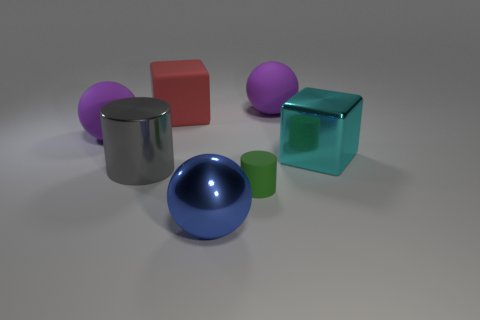Subtract all brown spheres. Subtract all gray cylinders. How many spheres are left? 3 Add 2 big red matte things. How many objects exist? 9 Subtract all cubes. How many objects are left? 5 Subtract all large cyan objects. Subtract all red blocks. How many objects are left? 5 Add 1 gray shiny objects. How many gray shiny objects are left? 2 Add 2 blue things. How many blue things exist? 3 Subtract 0 purple cylinders. How many objects are left? 7 